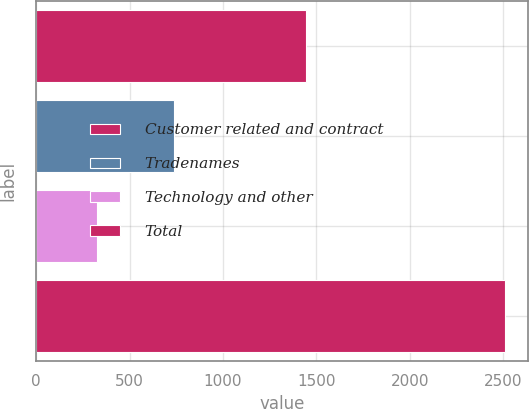Convert chart to OTSL. <chart><loc_0><loc_0><loc_500><loc_500><bar_chart><fcel>Customer related and contract<fcel>Tradenames<fcel>Technology and other<fcel>Total<nl><fcel>1444<fcel>740<fcel>325<fcel>2509<nl></chart> 